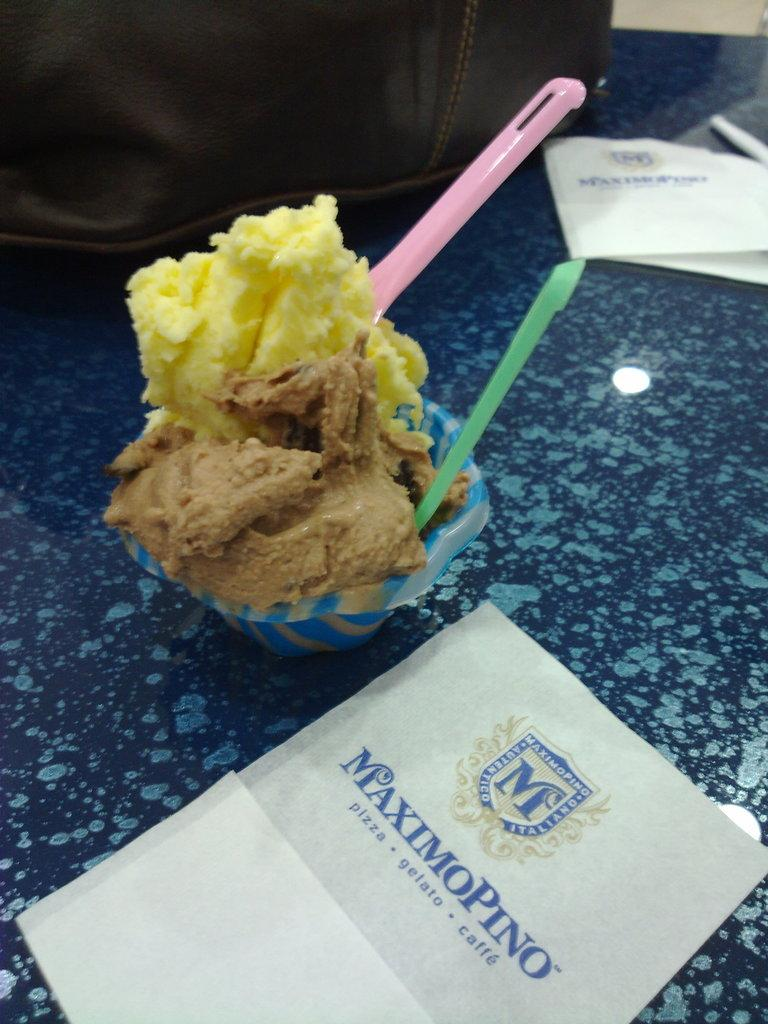What is inside the cup that is visible in the image? The cup contains ice-cream. How many spoons are visible in the image? There are two spoons in the image. What is written or depicted on the card at the bottom of the image? Unfortunately, the content of the card cannot be determined from the image. What is visible in the background of the image? A bag is visible in the background. Where are all the items placed in the image? All the items are placed on a table. What grade is the ice-cream in the cup? The concept of "grade" does not apply to ice-cream; it is a frozen dessert and not a school subject. How many sticks are used to hold the ice-cream in the cup? There are no sticks visible in the image; the ice-cream is contained within the cup. 